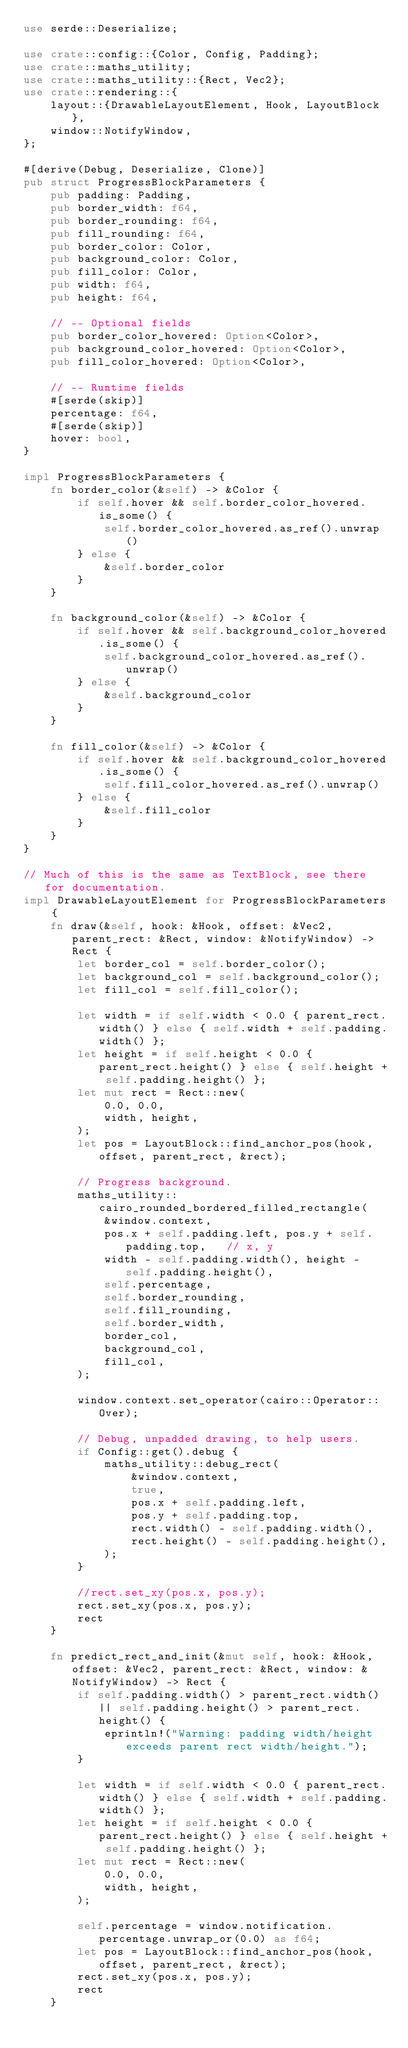<code> <loc_0><loc_0><loc_500><loc_500><_Rust_>use serde::Deserialize;

use crate::config::{Color, Config, Padding};
use crate::maths_utility;
use crate::maths_utility::{Rect, Vec2};
use crate::rendering::{
    layout::{DrawableLayoutElement, Hook, LayoutBlock},
    window::NotifyWindow,
};

#[derive(Debug, Deserialize, Clone)]
pub struct ProgressBlockParameters {
    pub padding: Padding,
    pub border_width: f64,
    pub border_rounding: f64,
    pub fill_rounding: f64,
    pub border_color: Color,
    pub background_color: Color,
    pub fill_color: Color,
    pub width: f64,
    pub height: f64,

    // -- Optional fields
    pub border_color_hovered: Option<Color>,
    pub background_color_hovered: Option<Color>,
    pub fill_color_hovered: Option<Color>,

    // -- Runtime fields
    #[serde(skip)]
    percentage: f64,
    #[serde(skip)]
    hover: bool,
}

impl ProgressBlockParameters {
    fn border_color(&self) -> &Color {
        if self.hover && self.border_color_hovered.is_some() {
            self.border_color_hovered.as_ref().unwrap()
        } else {
            &self.border_color
        }
    }

    fn background_color(&self) -> &Color {
        if self.hover && self.background_color_hovered.is_some() {
            self.background_color_hovered.as_ref().unwrap()
        } else {
            &self.background_color
        }
    }

    fn fill_color(&self) -> &Color {
        if self.hover && self.background_color_hovered.is_some() {
            self.fill_color_hovered.as_ref().unwrap()
        } else {
            &self.fill_color
        }
    }
}

// Much of this is the same as TextBlock, see there for documentation.
impl DrawableLayoutElement for ProgressBlockParameters {
    fn draw(&self, hook: &Hook, offset: &Vec2, parent_rect: &Rect, window: &NotifyWindow) -> Rect {
        let border_col = self.border_color();
        let background_col = self.background_color();
        let fill_col = self.fill_color();

        let width = if self.width < 0.0 { parent_rect.width() } else { self.width + self.padding.width() };
        let height = if self.height < 0.0 { parent_rect.height() } else { self.height + self.padding.height() };
        let mut rect = Rect::new(
            0.0, 0.0,
            width, height,
        );
        let pos = LayoutBlock::find_anchor_pos(hook, offset, parent_rect, &rect);

        // Progress background.
        maths_utility::cairo_rounded_bordered_filled_rectangle(
            &window.context,
            pos.x + self.padding.left, pos.y + self.padding.top,   // x, y
            width - self.padding.width(), height - self.padding.height(),
            self.percentage,
            self.border_rounding,
            self.fill_rounding,
            self.border_width,
            border_col,
            background_col,
            fill_col,
        );

        window.context.set_operator(cairo::Operator::Over);

        // Debug, unpadded drawing, to help users.
        if Config::get().debug {
            maths_utility::debug_rect(
                &window.context,
                true,
                pos.x + self.padding.left,
                pos.y + self.padding.top,
                rect.width() - self.padding.width(),
                rect.height() - self.padding.height(),
            );
        }

        //rect.set_xy(pos.x, pos.y);
        rect.set_xy(pos.x, pos.y);
        rect
    }

    fn predict_rect_and_init(&mut self, hook: &Hook, offset: &Vec2, parent_rect: &Rect, window: &NotifyWindow) -> Rect {
        if self.padding.width() > parent_rect.width() || self.padding.height() > parent_rect.height() {
            eprintln!("Warning: padding width/height exceeds parent rect width/height.");
        }

        let width = if self.width < 0.0 { parent_rect.width() } else { self.width + self.padding.width() };
        let height = if self.height < 0.0 { parent_rect.height() } else { self.height + self.padding.height() };
        let mut rect = Rect::new(
            0.0, 0.0,
            width, height,
        );

        self.percentage = window.notification.percentage.unwrap_or(0.0) as f64;
        let pos = LayoutBlock::find_anchor_pos(hook, offset, parent_rect, &rect);
        rect.set_xy(pos.x, pos.y);
        rect
    }
</code> 